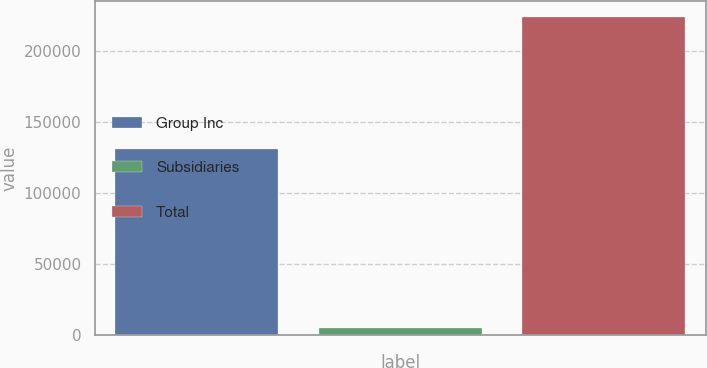Convert chart to OTSL. <chart><loc_0><loc_0><loc_500><loc_500><bar_chart><fcel>Group Inc<fcel>Subsidiaries<fcel>Total<nl><fcel>131384<fcel>5205<fcel>224149<nl></chart> 